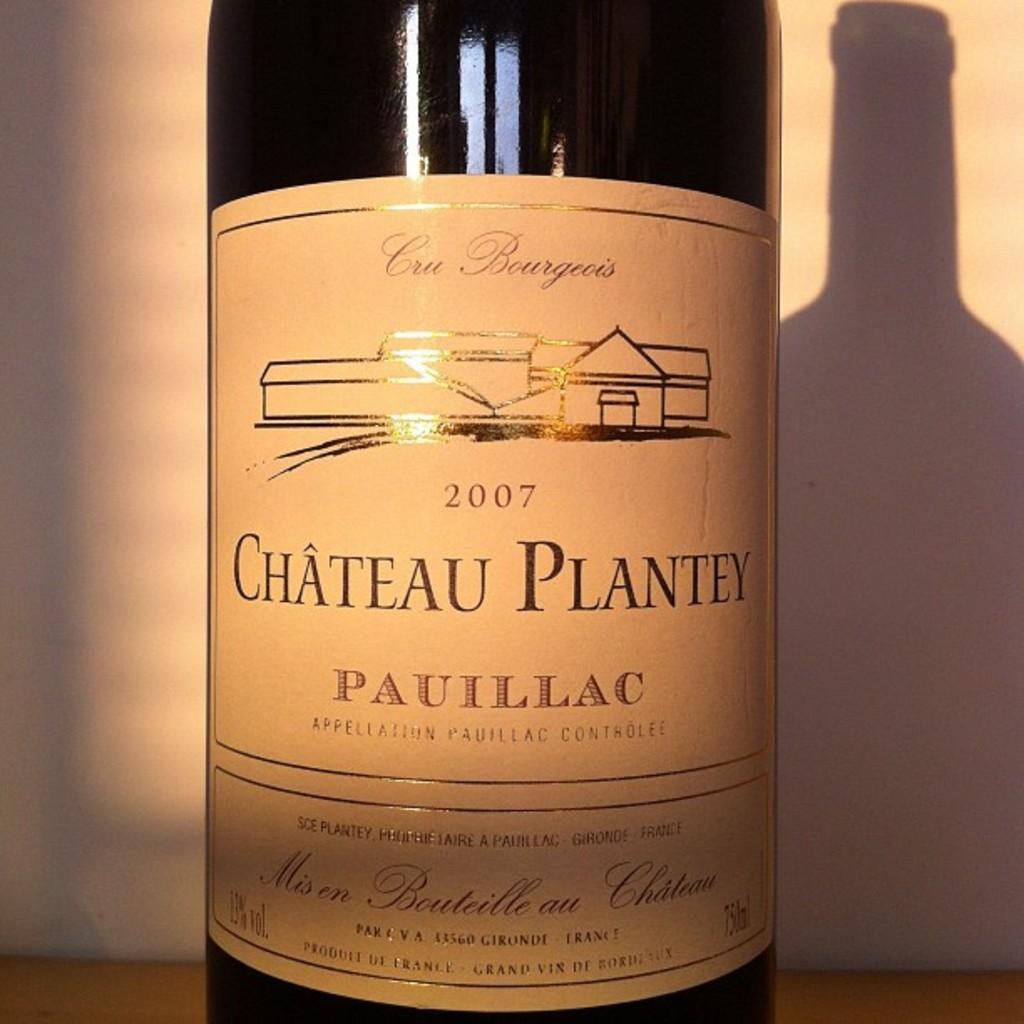What year is this bottle of wine?
Ensure brevity in your answer.  2007. Where was this wine made?
Your answer should be very brief. France. 